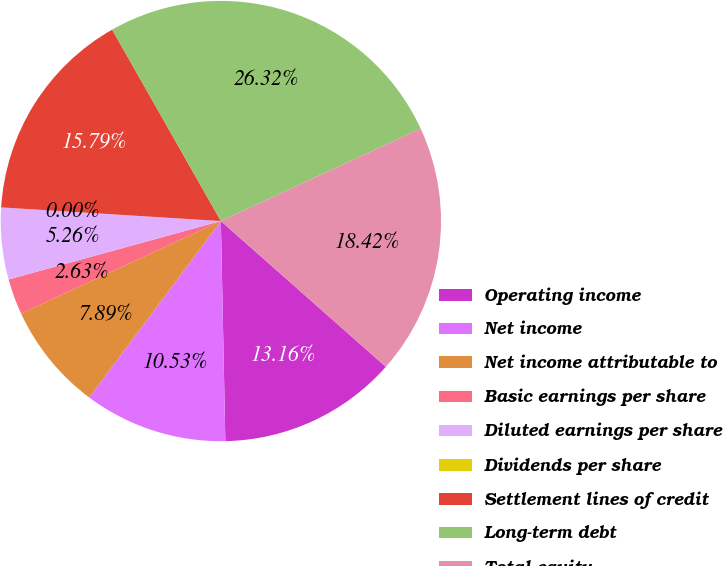Convert chart. <chart><loc_0><loc_0><loc_500><loc_500><pie_chart><fcel>Operating income<fcel>Net income<fcel>Net income attributable to<fcel>Basic earnings per share<fcel>Diluted earnings per share<fcel>Dividends per share<fcel>Settlement lines of credit<fcel>Long-term debt<fcel>Total equity<nl><fcel>13.16%<fcel>10.53%<fcel>7.89%<fcel>2.63%<fcel>5.26%<fcel>0.0%<fcel>15.79%<fcel>26.32%<fcel>18.42%<nl></chart> 